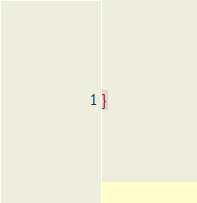Convert code to text. <code><loc_0><loc_0><loc_500><loc_500><_CSS_>}</code> 